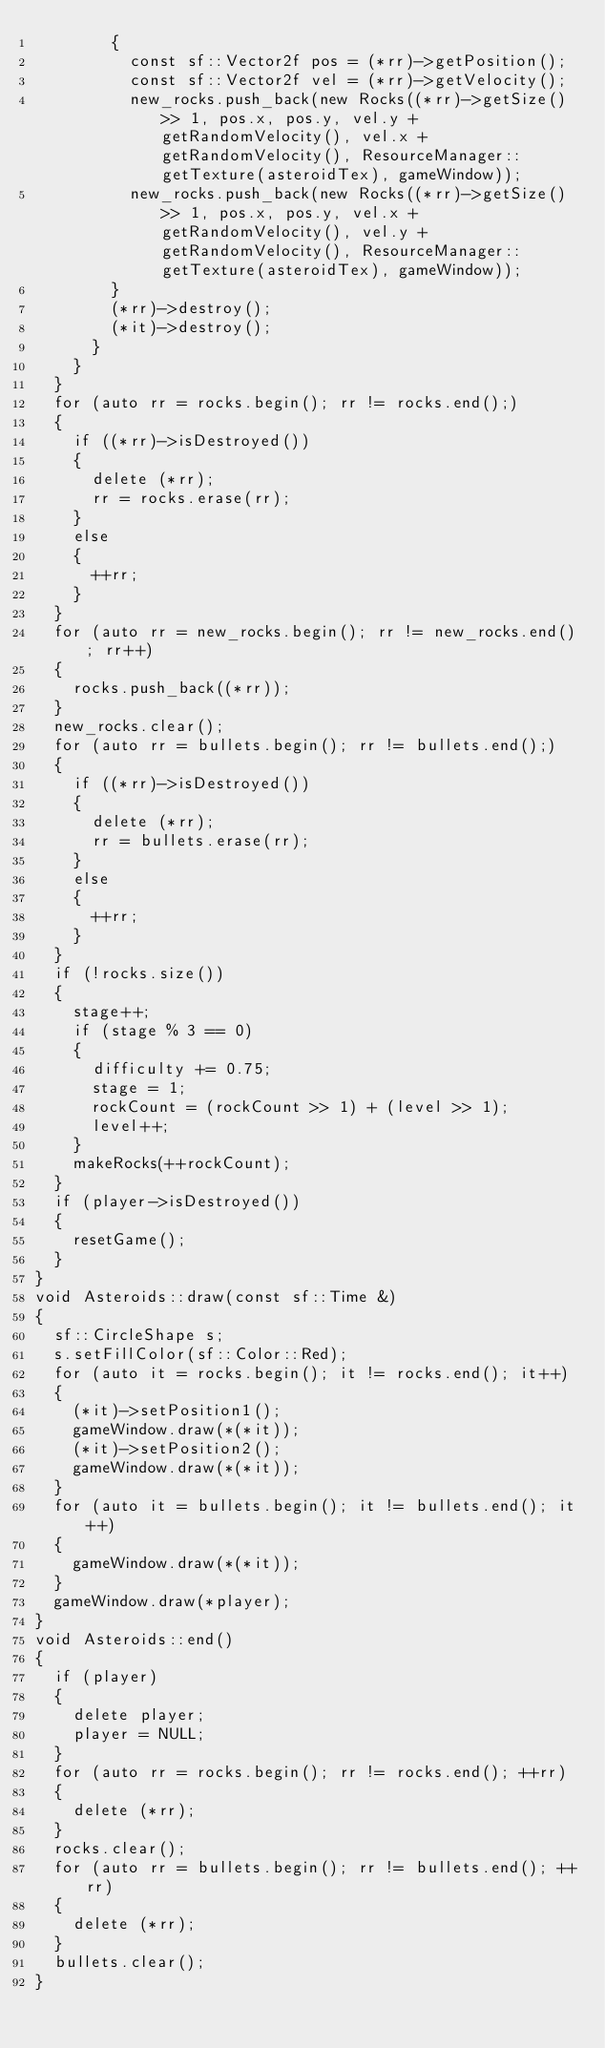<code> <loc_0><loc_0><loc_500><loc_500><_C++_>        {
          const sf::Vector2f pos = (*rr)->getPosition();
          const sf::Vector2f vel = (*rr)->getVelocity();
          new_rocks.push_back(new Rocks((*rr)->getSize() >> 1, pos.x, pos.y, vel.y + getRandomVelocity(), vel.x + getRandomVelocity(), ResourceManager::getTexture(asteroidTex), gameWindow));
          new_rocks.push_back(new Rocks((*rr)->getSize() >> 1, pos.x, pos.y, vel.x + getRandomVelocity(), vel.y + getRandomVelocity(), ResourceManager::getTexture(asteroidTex), gameWindow));
        }
        (*rr)->destroy();
        (*it)->destroy();
      }
    }
  }
  for (auto rr = rocks.begin(); rr != rocks.end();)
  {
    if ((*rr)->isDestroyed())
    {
      delete (*rr);
      rr = rocks.erase(rr);
    }
    else
    {
      ++rr;
    }
  }
  for (auto rr = new_rocks.begin(); rr != new_rocks.end(); rr++)
  {
    rocks.push_back((*rr));
  }
  new_rocks.clear();
  for (auto rr = bullets.begin(); rr != bullets.end();)
  {
    if ((*rr)->isDestroyed())
    {
      delete (*rr);
      rr = bullets.erase(rr);
    }
    else
    {
      ++rr;
    }
  }
  if (!rocks.size())
  {
    stage++;
    if (stage % 3 == 0)
    {
      difficulty += 0.75;
      stage = 1;
      rockCount = (rockCount >> 1) + (level >> 1);
      level++;
    }
    makeRocks(++rockCount);
  }
  if (player->isDestroyed())
  {
    resetGame();
  }
}
void Asteroids::draw(const sf::Time &)
{
  sf::CircleShape s;
  s.setFillColor(sf::Color::Red);
  for (auto it = rocks.begin(); it != rocks.end(); it++)
  {
    (*it)->setPosition1();
    gameWindow.draw(*(*it));
    (*it)->setPosition2();
    gameWindow.draw(*(*it));
  }
  for (auto it = bullets.begin(); it != bullets.end(); it++)
  {
    gameWindow.draw(*(*it));
  }
  gameWindow.draw(*player);
}
void Asteroids::end()
{
  if (player)
  {
    delete player;
    player = NULL;
  }
  for (auto rr = rocks.begin(); rr != rocks.end(); ++rr)
  {
    delete (*rr);
  }
  rocks.clear();
  for (auto rr = bullets.begin(); rr != bullets.end(); ++rr)
  {
    delete (*rr);
  }
  bullets.clear();
}</code> 